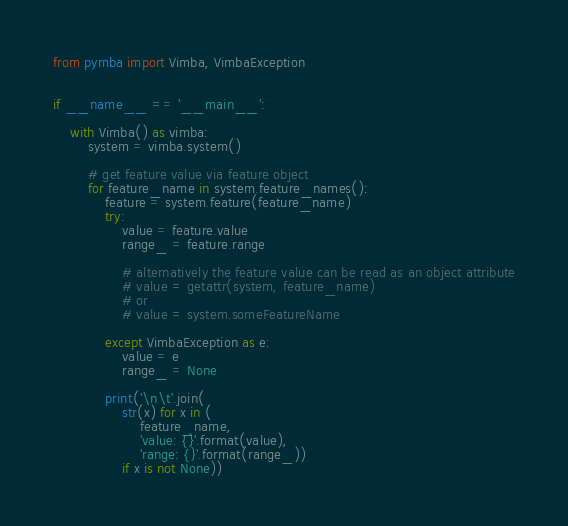Convert code to text. <code><loc_0><loc_0><loc_500><loc_500><_Python_>from pymba import Vimba, VimbaException


if __name__ == '__main__':

    with Vimba() as vimba:
        system = vimba.system()

        # get feature value via feature object
        for feature_name in system.feature_names():
            feature = system.feature(feature_name)
            try:
                value = feature.value
                range_ = feature.range

                # alternatively the feature value can be read as an object attribute
                # value = getattr(system, feature_name)
                # or
                # value = system.someFeatureName

            except VimbaException as e:
                value = e
                range_ = None

            print('\n\t'.join(
                str(x) for x in (
                    feature_name,
                    'value: {}'.format(value),
                    'range: {}'.format(range_))
                if x is not None))
</code> 